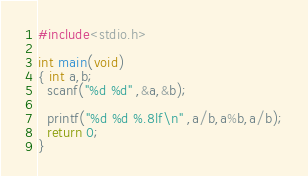<code> <loc_0><loc_0><loc_500><loc_500><_C_>#include<stdio.h>
 
int main(void)
{ int a,b;
  scanf("%d %d" ,&a,&b);
   
  printf("%d %d %.8lf\n" ,a/b,a%b,a/b);
  return 0;
}</code> 